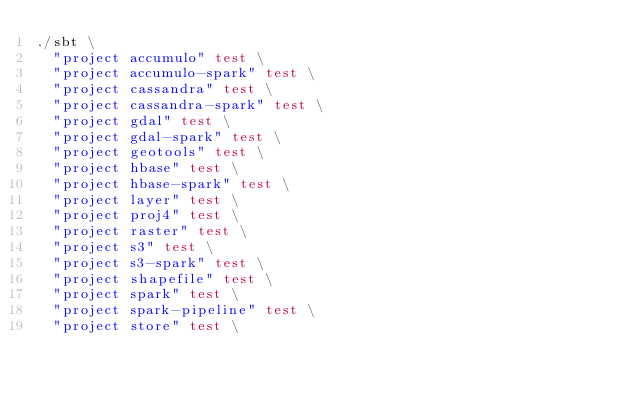Convert code to text. <code><loc_0><loc_0><loc_500><loc_500><_Bash_>./sbt \
  "project accumulo" test \
  "project accumulo-spark" test \
  "project cassandra" test \
  "project cassandra-spark" test \
  "project gdal" test \
  "project gdal-spark" test \
  "project geotools" test \
  "project hbase" test \
  "project hbase-spark" test \
  "project layer" test \
  "project proj4" test \
  "project raster" test \
  "project s3" test \
  "project s3-spark" test \
  "project shapefile" test \
  "project spark" test \
  "project spark-pipeline" test \
  "project store" test \</code> 